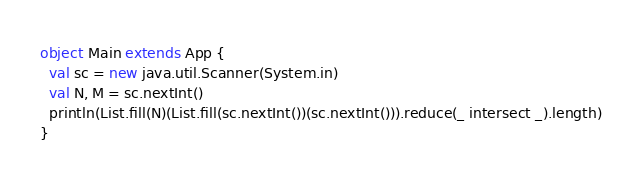<code> <loc_0><loc_0><loc_500><loc_500><_Scala_>object Main extends App {
  val sc = new java.util.Scanner(System.in)
  val N, M = sc.nextInt()
  println(List.fill(N)(List.fill(sc.nextInt())(sc.nextInt())).reduce(_ intersect _).length)
}</code> 